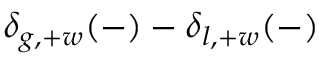Convert formula to latex. <formula><loc_0><loc_0><loc_500><loc_500>\delta _ { g , + w } ( - ) - \delta _ { l , + w } ( - )</formula> 